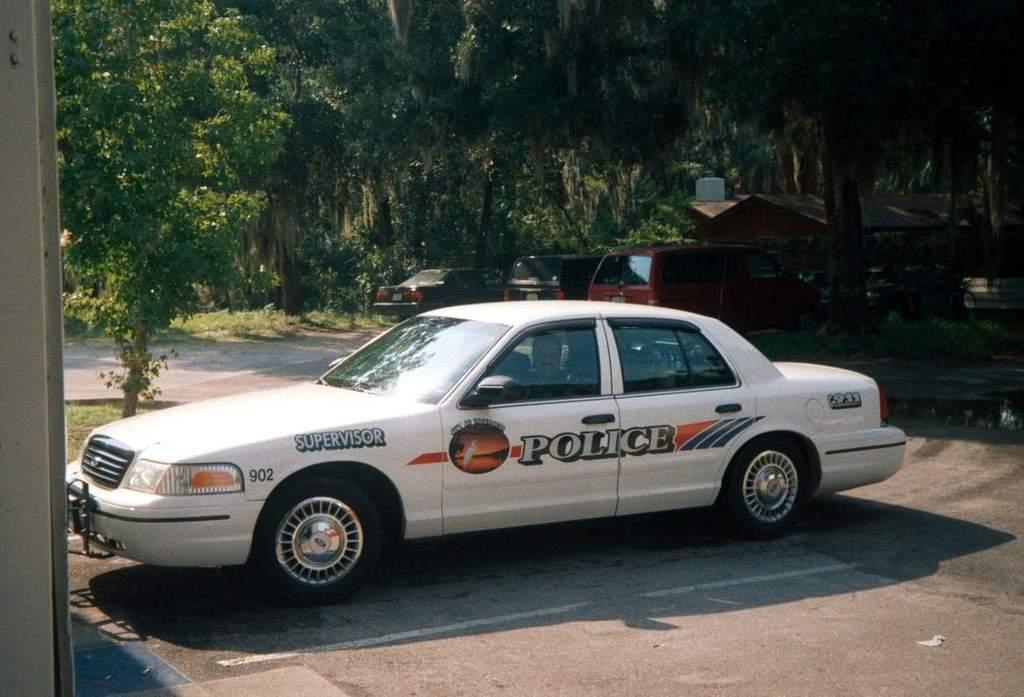How would you summarize this image in a sentence or two? In this image, we can see vehicles on the road and in the background, there are trees and we can see sheds. 